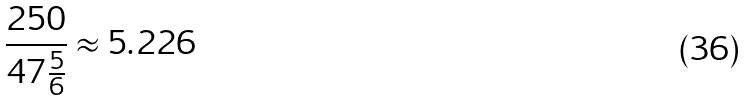<formula> <loc_0><loc_0><loc_500><loc_500>\frac { 2 5 0 } { 4 7 \frac { 5 } { 6 } } \approx 5 . 2 2 6</formula> 